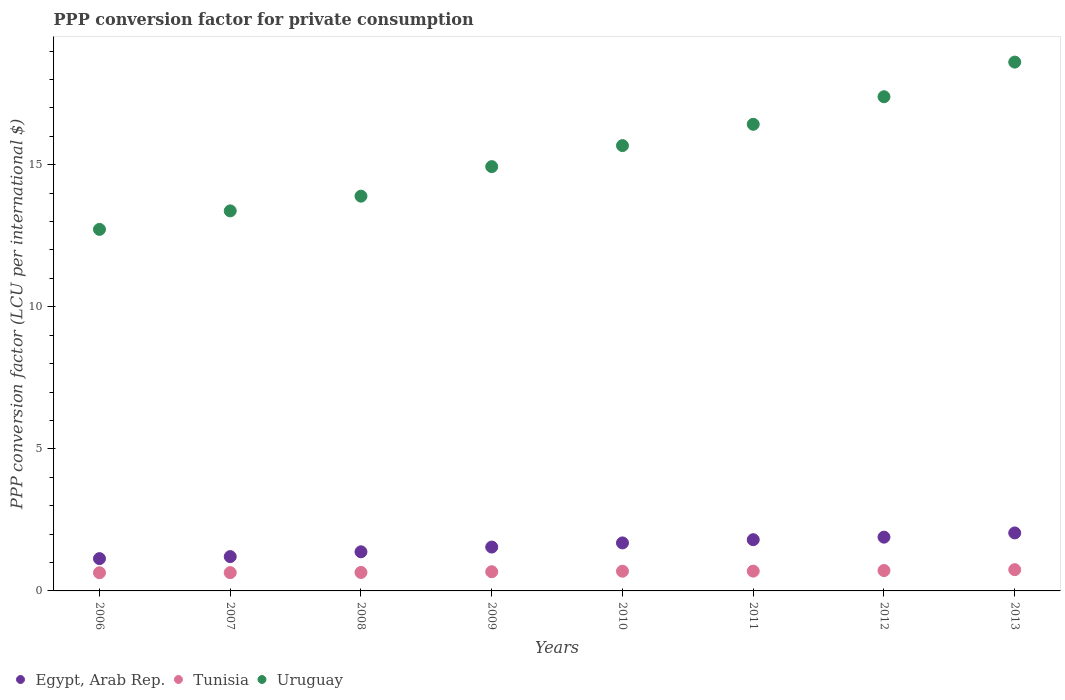How many different coloured dotlines are there?
Your answer should be compact. 3. Is the number of dotlines equal to the number of legend labels?
Make the answer very short. Yes. What is the PPP conversion factor for private consumption in Egypt, Arab Rep. in 2010?
Your answer should be compact. 1.69. Across all years, what is the maximum PPP conversion factor for private consumption in Uruguay?
Your response must be concise. 18.61. Across all years, what is the minimum PPP conversion factor for private consumption in Tunisia?
Keep it short and to the point. 0.64. In which year was the PPP conversion factor for private consumption in Egypt, Arab Rep. maximum?
Provide a succinct answer. 2013. In which year was the PPP conversion factor for private consumption in Tunisia minimum?
Ensure brevity in your answer.  2006. What is the total PPP conversion factor for private consumption in Tunisia in the graph?
Ensure brevity in your answer.  5.47. What is the difference between the PPP conversion factor for private consumption in Uruguay in 2007 and that in 2010?
Your answer should be very brief. -2.3. What is the difference between the PPP conversion factor for private consumption in Tunisia in 2006 and the PPP conversion factor for private consumption in Egypt, Arab Rep. in 2007?
Your response must be concise. -0.57. What is the average PPP conversion factor for private consumption in Egypt, Arab Rep. per year?
Keep it short and to the point. 1.59. In the year 2011, what is the difference between the PPP conversion factor for private consumption in Uruguay and PPP conversion factor for private consumption in Tunisia?
Your answer should be very brief. 15.73. In how many years, is the PPP conversion factor for private consumption in Tunisia greater than 18 LCU?
Offer a very short reply. 0. What is the ratio of the PPP conversion factor for private consumption in Egypt, Arab Rep. in 2008 to that in 2009?
Offer a very short reply. 0.89. Is the PPP conversion factor for private consumption in Egypt, Arab Rep. in 2006 less than that in 2011?
Provide a succinct answer. Yes. Is the difference between the PPP conversion factor for private consumption in Uruguay in 2008 and 2013 greater than the difference between the PPP conversion factor for private consumption in Tunisia in 2008 and 2013?
Make the answer very short. No. What is the difference between the highest and the second highest PPP conversion factor for private consumption in Uruguay?
Provide a short and direct response. 1.22. What is the difference between the highest and the lowest PPP conversion factor for private consumption in Uruguay?
Keep it short and to the point. 5.89. In how many years, is the PPP conversion factor for private consumption in Tunisia greater than the average PPP conversion factor for private consumption in Tunisia taken over all years?
Your answer should be very brief. 4. Is it the case that in every year, the sum of the PPP conversion factor for private consumption in Tunisia and PPP conversion factor for private consumption in Uruguay  is greater than the PPP conversion factor for private consumption in Egypt, Arab Rep.?
Your answer should be very brief. Yes. Does the PPP conversion factor for private consumption in Egypt, Arab Rep. monotonically increase over the years?
Offer a very short reply. Yes. Is the PPP conversion factor for private consumption in Egypt, Arab Rep. strictly greater than the PPP conversion factor for private consumption in Uruguay over the years?
Ensure brevity in your answer.  No. How many years are there in the graph?
Provide a succinct answer. 8. What is the difference between two consecutive major ticks on the Y-axis?
Your response must be concise. 5. Are the values on the major ticks of Y-axis written in scientific E-notation?
Give a very brief answer. No. Does the graph contain any zero values?
Give a very brief answer. No. Does the graph contain grids?
Offer a very short reply. No. How are the legend labels stacked?
Provide a short and direct response. Horizontal. What is the title of the graph?
Keep it short and to the point. PPP conversion factor for private consumption. What is the label or title of the X-axis?
Ensure brevity in your answer.  Years. What is the label or title of the Y-axis?
Offer a very short reply. PPP conversion factor (LCU per international $). What is the PPP conversion factor (LCU per international $) in Egypt, Arab Rep. in 2006?
Your answer should be very brief. 1.14. What is the PPP conversion factor (LCU per international $) of Tunisia in 2006?
Keep it short and to the point. 0.64. What is the PPP conversion factor (LCU per international $) of Uruguay in 2006?
Ensure brevity in your answer.  12.73. What is the PPP conversion factor (LCU per international $) in Egypt, Arab Rep. in 2007?
Give a very brief answer. 1.21. What is the PPP conversion factor (LCU per international $) of Tunisia in 2007?
Offer a very short reply. 0.64. What is the PPP conversion factor (LCU per international $) in Uruguay in 2007?
Offer a terse response. 13.38. What is the PPP conversion factor (LCU per international $) in Egypt, Arab Rep. in 2008?
Your answer should be compact. 1.38. What is the PPP conversion factor (LCU per international $) of Tunisia in 2008?
Offer a terse response. 0.65. What is the PPP conversion factor (LCU per international $) in Uruguay in 2008?
Your answer should be very brief. 13.89. What is the PPP conversion factor (LCU per international $) in Egypt, Arab Rep. in 2009?
Keep it short and to the point. 1.54. What is the PPP conversion factor (LCU per international $) in Tunisia in 2009?
Provide a succinct answer. 0.68. What is the PPP conversion factor (LCU per international $) of Uruguay in 2009?
Your response must be concise. 14.93. What is the PPP conversion factor (LCU per international $) of Egypt, Arab Rep. in 2010?
Offer a very short reply. 1.69. What is the PPP conversion factor (LCU per international $) in Tunisia in 2010?
Your answer should be compact. 0.69. What is the PPP conversion factor (LCU per international $) in Uruguay in 2010?
Your answer should be very brief. 15.67. What is the PPP conversion factor (LCU per international $) in Egypt, Arab Rep. in 2011?
Your response must be concise. 1.8. What is the PPP conversion factor (LCU per international $) in Tunisia in 2011?
Your answer should be very brief. 0.7. What is the PPP conversion factor (LCU per international $) in Uruguay in 2011?
Ensure brevity in your answer.  16.42. What is the PPP conversion factor (LCU per international $) in Egypt, Arab Rep. in 2012?
Keep it short and to the point. 1.89. What is the PPP conversion factor (LCU per international $) of Tunisia in 2012?
Your answer should be very brief. 0.72. What is the PPP conversion factor (LCU per international $) of Uruguay in 2012?
Provide a succinct answer. 17.39. What is the PPP conversion factor (LCU per international $) in Egypt, Arab Rep. in 2013?
Your answer should be compact. 2.04. What is the PPP conversion factor (LCU per international $) of Tunisia in 2013?
Ensure brevity in your answer.  0.75. What is the PPP conversion factor (LCU per international $) of Uruguay in 2013?
Your response must be concise. 18.61. Across all years, what is the maximum PPP conversion factor (LCU per international $) of Egypt, Arab Rep.?
Your answer should be compact. 2.04. Across all years, what is the maximum PPP conversion factor (LCU per international $) of Tunisia?
Your response must be concise. 0.75. Across all years, what is the maximum PPP conversion factor (LCU per international $) in Uruguay?
Your answer should be compact. 18.61. Across all years, what is the minimum PPP conversion factor (LCU per international $) of Egypt, Arab Rep.?
Offer a terse response. 1.14. Across all years, what is the minimum PPP conversion factor (LCU per international $) in Tunisia?
Your answer should be compact. 0.64. Across all years, what is the minimum PPP conversion factor (LCU per international $) in Uruguay?
Offer a very short reply. 12.73. What is the total PPP conversion factor (LCU per international $) in Egypt, Arab Rep. in the graph?
Make the answer very short. 12.69. What is the total PPP conversion factor (LCU per international $) of Tunisia in the graph?
Ensure brevity in your answer.  5.47. What is the total PPP conversion factor (LCU per international $) of Uruguay in the graph?
Offer a very short reply. 123.03. What is the difference between the PPP conversion factor (LCU per international $) of Egypt, Arab Rep. in 2006 and that in 2007?
Offer a terse response. -0.07. What is the difference between the PPP conversion factor (LCU per international $) in Tunisia in 2006 and that in 2007?
Your answer should be very brief. -0. What is the difference between the PPP conversion factor (LCU per international $) in Uruguay in 2006 and that in 2007?
Offer a very short reply. -0.65. What is the difference between the PPP conversion factor (LCU per international $) in Egypt, Arab Rep. in 2006 and that in 2008?
Provide a short and direct response. -0.24. What is the difference between the PPP conversion factor (LCU per international $) of Tunisia in 2006 and that in 2008?
Your response must be concise. -0.01. What is the difference between the PPP conversion factor (LCU per international $) of Uruguay in 2006 and that in 2008?
Your answer should be very brief. -1.17. What is the difference between the PPP conversion factor (LCU per international $) in Egypt, Arab Rep. in 2006 and that in 2009?
Make the answer very short. -0.41. What is the difference between the PPP conversion factor (LCU per international $) in Tunisia in 2006 and that in 2009?
Provide a succinct answer. -0.04. What is the difference between the PPP conversion factor (LCU per international $) in Uruguay in 2006 and that in 2009?
Give a very brief answer. -2.21. What is the difference between the PPP conversion factor (LCU per international $) of Egypt, Arab Rep. in 2006 and that in 2010?
Your answer should be very brief. -0.55. What is the difference between the PPP conversion factor (LCU per international $) in Tunisia in 2006 and that in 2010?
Provide a short and direct response. -0.05. What is the difference between the PPP conversion factor (LCU per international $) in Uruguay in 2006 and that in 2010?
Keep it short and to the point. -2.95. What is the difference between the PPP conversion factor (LCU per international $) in Egypt, Arab Rep. in 2006 and that in 2011?
Offer a terse response. -0.67. What is the difference between the PPP conversion factor (LCU per international $) of Tunisia in 2006 and that in 2011?
Offer a very short reply. -0.06. What is the difference between the PPP conversion factor (LCU per international $) of Uruguay in 2006 and that in 2011?
Your answer should be very brief. -3.7. What is the difference between the PPP conversion factor (LCU per international $) of Egypt, Arab Rep. in 2006 and that in 2012?
Offer a very short reply. -0.76. What is the difference between the PPP conversion factor (LCU per international $) in Tunisia in 2006 and that in 2012?
Give a very brief answer. -0.08. What is the difference between the PPP conversion factor (LCU per international $) in Uruguay in 2006 and that in 2012?
Offer a very short reply. -4.67. What is the difference between the PPP conversion factor (LCU per international $) of Egypt, Arab Rep. in 2006 and that in 2013?
Your response must be concise. -0.9. What is the difference between the PPP conversion factor (LCU per international $) in Tunisia in 2006 and that in 2013?
Keep it short and to the point. -0.11. What is the difference between the PPP conversion factor (LCU per international $) of Uruguay in 2006 and that in 2013?
Your response must be concise. -5.89. What is the difference between the PPP conversion factor (LCU per international $) in Egypt, Arab Rep. in 2007 and that in 2008?
Keep it short and to the point. -0.17. What is the difference between the PPP conversion factor (LCU per international $) of Tunisia in 2007 and that in 2008?
Your answer should be compact. -0.01. What is the difference between the PPP conversion factor (LCU per international $) of Uruguay in 2007 and that in 2008?
Ensure brevity in your answer.  -0.52. What is the difference between the PPP conversion factor (LCU per international $) in Egypt, Arab Rep. in 2007 and that in 2009?
Give a very brief answer. -0.34. What is the difference between the PPP conversion factor (LCU per international $) in Tunisia in 2007 and that in 2009?
Keep it short and to the point. -0.03. What is the difference between the PPP conversion factor (LCU per international $) in Uruguay in 2007 and that in 2009?
Keep it short and to the point. -1.56. What is the difference between the PPP conversion factor (LCU per international $) in Egypt, Arab Rep. in 2007 and that in 2010?
Your answer should be very brief. -0.48. What is the difference between the PPP conversion factor (LCU per international $) in Tunisia in 2007 and that in 2010?
Keep it short and to the point. -0.05. What is the difference between the PPP conversion factor (LCU per international $) of Uruguay in 2007 and that in 2010?
Offer a very short reply. -2.3. What is the difference between the PPP conversion factor (LCU per international $) of Egypt, Arab Rep. in 2007 and that in 2011?
Offer a very short reply. -0.59. What is the difference between the PPP conversion factor (LCU per international $) of Tunisia in 2007 and that in 2011?
Make the answer very short. -0.05. What is the difference between the PPP conversion factor (LCU per international $) in Uruguay in 2007 and that in 2011?
Ensure brevity in your answer.  -3.05. What is the difference between the PPP conversion factor (LCU per international $) in Egypt, Arab Rep. in 2007 and that in 2012?
Your answer should be compact. -0.68. What is the difference between the PPP conversion factor (LCU per international $) in Tunisia in 2007 and that in 2012?
Ensure brevity in your answer.  -0.07. What is the difference between the PPP conversion factor (LCU per international $) in Uruguay in 2007 and that in 2012?
Offer a terse response. -4.02. What is the difference between the PPP conversion factor (LCU per international $) of Egypt, Arab Rep. in 2007 and that in 2013?
Your response must be concise. -0.83. What is the difference between the PPP conversion factor (LCU per international $) of Tunisia in 2007 and that in 2013?
Offer a terse response. -0.1. What is the difference between the PPP conversion factor (LCU per international $) of Uruguay in 2007 and that in 2013?
Make the answer very short. -5.24. What is the difference between the PPP conversion factor (LCU per international $) of Egypt, Arab Rep. in 2008 and that in 2009?
Offer a terse response. -0.17. What is the difference between the PPP conversion factor (LCU per international $) of Tunisia in 2008 and that in 2009?
Provide a succinct answer. -0.03. What is the difference between the PPP conversion factor (LCU per international $) in Uruguay in 2008 and that in 2009?
Provide a succinct answer. -1.04. What is the difference between the PPP conversion factor (LCU per international $) of Egypt, Arab Rep. in 2008 and that in 2010?
Keep it short and to the point. -0.31. What is the difference between the PPP conversion factor (LCU per international $) of Tunisia in 2008 and that in 2010?
Your answer should be very brief. -0.04. What is the difference between the PPP conversion factor (LCU per international $) of Uruguay in 2008 and that in 2010?
Provide a short and direct response. -1.78. What is the difference between the PPP conversion factor (LCU per international $) of Egypt, Arab Rep. in 2008 and that in 2011?
Provide a short and direct response. -0.43. What is the difference between the PPP conversion factor (LCU per international $) of Tunisia in 2008 and that in 2011?
Offer a very short reply. -0.05. What is the difference between the PPP conversion factor (LCU per international $) in Uruguay in 2008 and that in 2011?
Provide a succinct answer. -2.53. What is the difference between the PPP conversion factor (LCU per international $) in Egypt, Arab Rep. in 2008 and that in 2012?
Offer a very short reply. -0.52. What is the difference between the PPP conversion factor (LCU per international $) in Tunisia in 2008 and that in 2012?
Give a very brief answer. -0.07. What is the difference between the PPP conversion factor (LCU per international $) of Uruguay in 2008 and that in 2012?
Your response must be concise. -3.5. What is the difference between the PPP conversion factor (LCU per international $) in Egypt, Arab Rep. in 2008 and that in 2013?
Provide a short and direct response. -0.66. What is the difference between the PPP conversion factor (LCU per international $) of Tunisia in 2008 and that in 2013?
Make the answer very short. -0.1. What is the difference between the PPP conversion factor (LCU per international $) in Uruguay in 2008 and that in 2013?
Ensure brevity in your answer.  -4.72. What is the difference between the PPP conversion factor (LCU per international $) in Egypt, Arab Rep. in 2009 and that in 2010?
Make the answer very short. -0.15. What is the difference between the PPP conversion factor (LCU per international $) in Tunisia in 2009 and that in 2010?
Provide a short and direct response. -0.02. What is the difference between the PPP conversion factor (LCU per international $) in Uruguay in 2009 and that in 2010?
Offer a very short reply. -0.74. What is the difference between the PPP conversion factor (LCU per international $) in Egypt, Arab Rep. in 2009 and that in 2011?
Ensure brevity in your answer.  -0.26. What is the difference between the PPP conversion factor (LCU per international $) of Tunisia in 2009 and that in 2011?
Keep it short and to the point. -0.02. What is the difference between the PPP conversion factor (LCU per international $) of Uruguay in 2009 and that in 2011?
Provide a succinct answer. -1.49. What is the difference between the PPP conversion factor (LCU per international $) of Egypt, Arab Rep. in 2009 and that in 2012?
Provide a succinct answer. -0.35. What is the difference between the PPP conversion factor (LCU per international $) in Tunisia in 2009 and that in 2012?
Offer a terse response. -0.04. What is the difference between the PPP conversion factor (LCU per international $) in Uruguay in 2009 and that in 2012?
Your response must be concise. -2.46. What is the difference between the PPP conversion factor (LCU per international $) in Egypt, Arab Rep. in 2009 and that in 2013?
Provide a short and direct response. -0.5. What is the difference between the PPP conversion factor (LCU per international $) of Tunisia in 2009 and that in 2013?
Your answer should be very brief. -0.07. What is the difference between the PPP conversion factor (LCU per international $) of Uruguay in 2009 and that in 2013?
Make the answer very short. -3.68. What is the difference between the PPP conversion factor (LCU per international $) in Egypt, Arab Rep. in 2010 and that in 2011?
Provide a short and direct response. -0.11. What is the difference between the PPP conversion factor (LCU per international $) in Tunisia in 2010 and that in 2011?
Your answer should be compact. -0. What is the difference between the PPP conversion factor (LCU per international $) in Uruguay in 2010 and that in 2011?
Provide a succinct answer. -0.75. What is the difference between the PPP conversion factor (LCU per international $) of Egypt, Arab Rep. in 2010 and that in 2012?
Provide a succinct answer. -0.2. What is the difference between the PPP conversion factor (LCU per international $) of Tunisia in 2010 and that in 2012?
Keep it short and to the point. -0.02. What is the difference between the PPP conversion factor (LCU per international $) in Uruguay in 2010 and that in 2012?
Give a very brief answer. -1.72. What is the difference between the PPP conversion factor (LCU per international $) in Egypt, Arab Rep. in 2010 and that in 2013?
Your answer should be compact. -0.35. What is the difference between the PPP conversion factor (LCU per international $) of Tunisia in 2010 and that in 2013?
Offer a very short reply. -0.05. What is the difference between the PPP conversion factor (LCU per international $) in Uruguay in 2010 and that in 2013?
Provide a short and direct response. -2.94. What is the difference between the PPP conversion factor (LCU per international $) of Egypt, Arab Rep. in 2011 and that in 2012?
Offer a terse response. -0.09. What is the difference between the PPP conversion factor (LCU per international $) in Tunisia in 2011 and that in 2012?
Your response must be concise. -0.02. What is the difference between the PPP conversion factor (LCU per international $) of Uruguay in 2011 and that in 2012?
Offer a terse response. -0.97. What is the difference between the PPP conversion factor (LCU per international $) in Egypt, Arab Rep. in 2011 and that in 2013?
Give a very brief answer. -0.24. What is the difference between the PPP conversion factor (LCU per international $) in Tunisia in 2011 and that in 2013?
Make the answer very short. -0.05. What is the difference between the PPP conversion factor (LCU per international $) of Uruguay in 2011 and that in 2013?
Your answer should be compact. -2.19. What is the difference between the PPP conversion factor (LCU per international $) of Egypt, Arab Rep. in 2012 and that in 2013?
Give a very brief answer. -0.15. What is the difference between the PPP conversion factor (LCU per international $) of Tunisia in 2012 and that in 2013?
Your response must be concise. -0.03. What is the difference between the PPP conversion factor (LCU per international $) of Uruguay in 2012 and that in 2013?
Offer a terse response. -1.22. What is the difference between the PPP conversion factor (LCU per international $) of Egypt, Arab Rep. in 2006 and the PPP conversion factor (LCU per international $) of Tunisia in 2007?
Provide a short and direct response. 0.49. What is the difference between the PPP conversion factor (LCU per international $) in Egypt, Arab Rep. in 2006 and the PPP conversion factor (LCU per international $) in Uruguay in 2007?
Provide a succinct answer. -12.24. What is the difference between the PPP conversion factor (LCU per international $) of Tunisia in 2006 and the PPP conversion factor (LCU per international $) of Uruguay in 2007?
Your answer should be compact. -12.74. What is the difference between the PPP conversion factor (LCU per international $) in Egypt, Arab Rep. in 2006 and the PPP conversion factor (LCU per international $) in Tunisia in 2008?
Offer a terse response. 0.49. What is the difference between the PPP conversion factor (LCU per international $) of Egypt, Arab Rep. in 2006 and the PPP conversion factor (LCU per international $) of Uruguay in 2008?
Keep it short and to the point. -12.76. What is the difference between the PPP conversion factor (LCU per international $) of Tunisia in 2006 and the PPP conversion factor (LCU per international $) of Uruguay in 2008?
Make the answer very short. -13.25. What is the difference between the PPP conversion factor (LCU per international $) of Egypt, Arab Rep. in 2006 and the PPP conversion factor (LCU per international $) of Tunisia in 2009?
Give a very brief answer. 0.46. What is the difference between the PPP conversion factor (LCU per international $) in Egypt, Arab Rep. in 2006 and the PPP conversion factor (LCU per international $) in Uruguay in 2009?
Keep it short and to the point. -13.8. What is the difference between the PPP conversion factor (LCU per international $) of Tunisia in 2006 and the PPP conversion factor (LCU per international $) of Uruguay in 2009?
Offer a very short reply. -14.29. What is the difference between the PPP conversion factor (LCU per international $) in Egypt, Arab Rep. in 2006 and the PPP conversion factor (LCU per international $) in Tunisia in 2010?
Give a very brief answer. 0.44. What is the difference between the PPP conversion factor (LCU per international $) in Egypt, Arab Rep. in 2006 and the PPP conversion factor (LCU per international $) in Uruguay in 2010?
Make the answer very short. -14.54. What is the difference between the PPP conversion factor (LCU per international $) in Tunisia in 2006 and the PPP conversion factor (LCU per international $) in Uruguay in 2010?
Make the answer very short. -15.03. What is the difference between the PPP conversion factor (LCU per international $) in Egypt, Arab Rep. in 2006 and the PPP conversion factor (LCU per international $) in Tunisia in 2011?
Provide a succinct answer. 0.44. What is the difference between the PPP conversion factor (LCU per international $) of Egypt, Arab Rep. in 2006 and the PPP conversion factor (LCU per international $) of Uruguay in 2011?
Ensure brevity in your answer.  -15.29. What is the difference between the PPP conversion factor (LCU per international $) of Tunisia in 2006 and the PPP conversion factor (LCU per international $) of Uruguay in 2011?
Make the answer very short. -15.78. What is the difference between the PPP conversion factor (LCU per international $) of Egypt, Arab Rep. in 2006 and the PPP conversion factor (LCU per international $) of Tunisia in 2012?
Make the answer very short. 0.42. What is the difference between the PPP conversion factor (LCU per international $) in Egypt, Arab Rep. in 2006 and the PPP conversion factor (LCU per international $) in Uruguay in 2012?
Your answer should be compact. -16.26. What is the difference between the PPP conversion factor (LCU per international $) of Tunisia in 2006 and the PPP conversion factor (LCU per international $) of Uruguay in 2012?
Provide a succinct answer. -16.75. What is the difference between the PPP conversion factor (LCU per international $) in Egypt, Arab Rep. in 2006 and the PPP conversion factor (LCU per international $) in Tunisia in 2013?
Your answer should be very brief. 0.39. What is the difference between the PPP conversion factor (LCU per international $) in Egypt, Arab Rep. in 2006 and the PPP conversion factor (LCU per international $) in Uruguay in 2013?
Ensure brevity in your answer.  -17.48. What is the difference between the PPP conversion factor (LCU per international $) of Tunisia in 2006 and the PPP conversion factor (LCU per international $) of Uruguay in 2013?
Ensure brevity in your answer.  -17.97. What is the difference between the PPP conversion factor (LCU per international $) of Egypt, Arab Rep. in 2007 and the PPP conversion factor (LCU per international $) of Tunisia in 2008?
Ensure brevity in your answer.  0.56. What is the difference between the PPP conversion factor (LCU per international $) in Egypt, Arab Rep. in 2007 and the PPP conversion factor (LCU per international $) in Uruguay in 2008?
Make the answer very short. -12.69. What is the difference between the PPP conversion factor (LCU per international $) in Tunisia in 2007 and the PPP conversion factor (LCU per international $) in Uruguay in 2008?
Offer a very short reply. -13.25. What is the difference between the PPP conversion factor (LCU per international $) in Egypt, Arab Rep. in 2007 and the PPP conversion factor (LCU per international $) in Tunisia in 2009?
Offer a terse response. 0.53. What is the difference between the PPP conversion factor (LCU per international $) in Egypt, Arab Rep. in 2007 and the PPP conversion factor (LCU per international $) in Uruguay in 2009?
Make the answer very short. -13.73. What is the difference between the PPP conversion factor (LCU per international $) in Tunisia in 2007 and the PPP conversion factor (LCU per international $) in Uruguay in 2009?
Offer a terse response. -14.29. What is the difference between the PPP conversion factor (LCU per international $) of Egypt, Arab Rep. in 2007 and the PPP conversion factor (LCU per international $) of Tunisia in 2010?
Offer a terse response. 0.51. What is the difference between the PPP conversion factor (LCU per international $) in Egypt, Arab Rep. in 2007 and the PPP conversion factor (LCU per international $) in Uruguay in 2010?
Provide a short and direct response. -14.47. What is the difference between the PPP conversion factor (LCU per international $) of Tunisia in 2007 and the PPP conversion factor (LCU per international $) of Uruguay in 2010?
Your answer should be compact. -15.03. What is the difference between the PPP conversion factor (LCU per international $) of Egypt, Arab Rep. in 2007 and the PPP conversion factor (LCU per international $) of Tunisia in 2011?
Offer a very short reply. 0.51. What is the difference between the PPP conversion factor (LCU per international $) of Egypt, Arab Rep. in 2007 and the PPP conversion factor (LCU per international $) of Uruguay in 2011?
Your response must be concise. -15.22. What is the difference between the PPP conversion factor (LCU per international $) of Tunisia in 2007 and the PPP conversion factor (LCU per international $) of Uruguay in 2011?
Keep it short and to the point. -15.78. What is the difference between the PPP conversion factor (LCU per international $) of Egypt, Arab Rep. in 2007 and the PPP conversion factor (LCU per international $) of Tunisia in 2012?
Offer a terse response. 0.49. What is the difference between the PPP conversion factor (LCU per international $) of Egypt, Arab Rep. in 2007 and the PPP conversion factor (LCU per international $) of Uruguay in 2012?
Provide a short and direct response. -16.19. What is the difference between the PPP conversion factor (LCU per international $) of Tunisia in 2007 and the PPP conversion factor (LCU per international $) of Uruguay in 2012?
Your answer should be compact. -16.75. What is the difference between the PPP conversion factor (LCU per international $) in Egypt, Arab Rep. in 2007 and the PPP conversion factor (LCU per international $) in Tunisia in 2013?
Offer a terse response. 0.46. What is the difference between the PPP conversion factor (LCU per international $) of Egypt, Arab Rep. in 2007 and the PPP conversion factor (LCU per international $) of Uruguay in 2013?
Ensure brevity in your answer.  -17.4. What is the difference between the PPP conversion factor (LCU per international $) in Tunisia in 2007 and the PPP conversion factor (LCU per international $) in Uruguay in 2013?
Keep it short and to the point. -17.97. What is the difference between the PPP conversion factor (LCU per international $) of Egypt, Arab Rep. in 2008 and the PPP conversion factor (LCU per international $) of Tunisia in 2009?
Your response must be concise. 0.7. What is the difference between the PPP conversion factor (LCU per international $) in Egypt, Arab Rep. in 2008 and the PPP conversion factor (LCU per international $) in Uruguay in 2009?
Provide a succinct answer. -13.56. What is the difference between the PPP conversion factor (LCU per international $) of Tunisia in 2008 and the PPP conversion factor (LCU per international $) of Uruguay in 2009?
Offer a terse response. -14.28. What is the difference between the PPP conversion factor (LCU per international $) of Egypt, Arab Rep. in 2008 and the PPP conversion factor (LCU per international $) of Tunisia in 2010?
Make the answer very short. 0.68. What is the difference between the PPP conversion factor (LCU per international $) of Egypt, Arab Rep. in 2008 and the PPP conversion factor (LCU per international $) of Uruguay in 2010?
Keep it short and to the point. -14.3. What is the difference between the PPP conversion factor (LCU per international $) in Tunisia in 2008 and the PPP conversion factor (LCU per international $) in Uruguay in 2010?
Make the answer very short. -15.02. What is the difference between the PPP conversion factor (LCU per international $) in Egypt, Arab Rep. in 2008 and the PPP conversion factor (LCU per international $) in Tunisia in 2011?
Ensure brevity in your answer.  0.68. What is the difference between the PPP conversion factor (LCU per international $) in Egypt, Arab Rep. in 2008 and the PPP conversion factor (LCU per international $) in Uruguay in 2011?
Provide a short and direct response. -15.05. What is the difference between the PPP conversion factor (LCU per international $) of Tunisia in 2008 and the PPP conversion factor (LCU per international $) of Uruguay in 2011?
Your answer should be very brief. -15.77. What is the difference between the PPP conversion factor (LCU per international $) of Egypt, Arab Rep. in 2008 and the PPP conversion factor (LCU per international $) of Tunisia in 2012?
Provide a succinct answer. 0.66. What is the difference between the PPP conversion factor (LCU per international $) of Egypt, Arab Rep. in 2008 and the PPP conversion factor (LCU per international $) of Uruguay in 2012?
Keep it short and to the point. -16.02. What is the difference between the PPP conversion factor (LCU per international $) of Tunisia in 2008 and the PPP conversion factor (LCU per international $) of Uruguay in 2012?
Give a very brief answer. -16.74. What is the difference between the PPP conversion factor (LCU per international $) in Egypt, Arab Rep. in 2008 and the PPP conversion factor (LCU per international $) in Tunisia in 2013?
Keep it short and to the point. 0.63. What is the difference between the PPP conversion factor (LCU per international $) of Egypt, Arab Rep. in 2008 and the PPP conversion factor (LCU per international $) of Uruguay in 2013?
Provide a short and direct response. -17.24. What is the difference between the PPP conversion factor (LCU per international $) of Tunisia in 2008 and the PPP conversion factor (LCU per international $) of Uruguay in 2013?
Ensure brevity in your answer.  -17.96. What is the difference between the PPP conversion factor (LCU per international $) in Egypt, Arab Rep. in 2009 and the PPP conversion factor (LCU per international $) in Tunisia in 2010?
Give a very brief answer. 0.85. What is the difference between the PPP conversion factor (LCU per international $) of Egypt, Arab Rep. in 2009 and the PPP conversion factor (LCU per international $) of Uruguay in 2010?
Provide a succinct answer. -14.13. What is the difference between the PPP conversion factor (LCU per international $) in Tunisia in 2009 and the PPP conversion factor (LCU per international $) in Uruguay in 2010?
Your answer should be very brief. -15. What is the difference between the PPP conversion factor (LCU per international $) of Egypt, Arab Rep. in 2009 and the PPP conversion factor (LCU per international $) of Tunisia in 2011?
Offer a terse response. 0.85. What is the difference between the PPP conversion factor (LCU per international $) of Egypt, Arab Rep. in 2009 and the PPP conversion factor (LCU per international $) of Uruguay in 2011?
Your answer should be compact. -14.88. What is the difference between the PPP conversion factor (LCU per international $) in Tunisia in 2009 and the PPP conversion factor (LCU per international $) in Uruguay in 2011?
Your answer should be very brief. -15.75. What is the difference between the PPP conversion factor (LCU per international $) of Egypt, Arab Rep. in 2009 and the PPP conversion factor (LCU per international $) of Tunisia in 2012?
Provide a short and direct response. 0.83. What is the difference between the PPP conversion factor (LCU per international $) of Egypt, Arab Rep. in 2009 and the PPP conversion factor (LCU per international $) of Uruguay in 2012?
Your answer should be very brief. -15.85. What is the difference between the PPP conversion factor (LCU per international $) of Tunisia in 2009 and the PPP conversion factor (LCU per international $) of Uruguay in 2012?
Provide a short and direct response. -16.72. What is the difference between the PPP conversion factor (LCU per international $) of Egypt, Arab Rep. in 2009 and the PPP conversion factor (LCU per international $) of Tunisia in 2013?
Your answer should be very brief. 0.8. What is the difference between the PPP conversion factor (LCU per international $) of Egypt, Arab Rep. in 2009 and the PPP conversion factor (LCU per international $) of Uruguay in 2013?
Provide a succinct answer. -17.07. What is the difference between the PPP conversion factor (LCU per international $) of Tunisia in 2009 and the PPP conversion factor (LCU per international $) of Uruguay in 2013?
Ensure brevity in your answer.  -17.94. What is the difference between the PPP conversion factor (LCU per international $) of Egypt, Arab Rep. in 2010 and the PPP conversion factor (LCU per international $) of Tunisia in 2011?
Give a very brief answer. 0.99. What is the difference between the PPP conversion factor (LCU per international $) of Egypt, Arab Rep. in 2010 and the PPP conversion factor (LCU per international $) of Uruguay in 2011?
Provide a succinct answer. -14.73. What is the difference between the PPP conversion factor (LCU per international $) in Tunisia in 2010 and the PPP conversion factor (LCU per international $) in Uruguay in 2011?
Your answer should be compact. -15.73. What is the difference between the PPP conversion factor (LCU per international $) in Egypt, Arab Rep. in 2010 and the PPP conversion factor (LCU per international $) in Tunisia in 2012?
Offer a terse response. 0.97. What is the difference between the PPP conversion factor (LCU per international $) of Egypt, Arab Rep. in 2010 and the PPP conversion factor (LCU per international $) of Uruguay in 2012?
Your answer should be compact. -15.7. What is the difference between the PPP conversion factor (LCU per international $) in Tunisia in 2010 and the PPP conversion factor (LCU per international $) in Uruguay in 2012?
Give a very brief answer. -16.7. What is the difference between the PPP conversion factor (LCU per international $) of Egypt, Arab Rep. in 2010 and the PPP conversion factor (LCU per international $) of Tunisia in 2013?
Provide a short and direct response. 0.94. What is the difference between the PPP conversion factor (LCU per international $) of Egypt, Arab Rep. in 2010 and the PPP conversion factor (LCU per international $) of Uruguay in 2013?
Provide a short and direct response. -16.92. What is the difference between the PPP conversion factor (LCU per international $) in Tunisia in 2010 and the PPP conversion factor (LCU per international $) in Uruguay in 2013?
Your answer should be very brief. -17.92. What is the difference between the PPP conversion factor (LCU per international $) of Egypt, Arab Rep. in 2011 and the PPP conversion factor (LCU per international $) of Tunisia in 2012?
Your answer should be compact. 1.09. What is the difference between the PPP conversion factor (LCU per international $) in Egypt, Arab Rep. in 2011 and the PPP conversion factor (LCU per international $) in Uruguay in 2012?
Give a very brief answer. -15.59. What is the difference between the PPP conversion factor (LCU per international $) of Tunisia in 2011 and the PPP conversion factor (LCU per international $) of Uruguay in 2012?
Your response must be concise. -16.7. What is the difference between the PPP conversion factor (LCU per international $) in Egypt, Arab Rep. in 2011 and the PPP conversion factor (LCU per international $) in Tunisia in 2013?
Offer a terse response. 1.05. What is the difference between the PPP conversion factor (LCU per international $) in Egypt, Arab Rep. in 2011 and the PPP conversion factor (LCU per international $) in Uruguay in 2013?
Your answer should be very brief. -16.81. What is the difference between the PPP conversion factor (LCU per international $) of Tunisia in 2011 and the PPP conversion factor (LCU per international $) of Uruguay in 2013?
Offer a very short reply. -17.92. What is the difference between the PPP conversion factor (LCU per international $) of Egypt, Arab Rep. in 2012 and the PPP conversion factor (LCU per international $) of Tunisia in 2013?
Offer a terse response. 1.14. What is the difference between the PPP conversion factor (LCU per international $) in Egypt, Arab Rep. in 2012 and the PPP conversion factor (LCU per international $) in Uruguay in 2013?
Offer a terse response. -16.72. What is the difference between the PPP conversion factor (LCU per international $) of Tunisia in 2012 and the PPP conversion factor (LCU per international $) of Uruguay in 2013?
Your answer should be compact. -17.9. What is the average PPP conversion factor (LCU per international $) in Egypt, Arab Rep. per year?
Your response must be concise. 1.59. What is the average PPP conversion factor (LCU per international $) of Tunisia per year?
Provide a short and direct response. 0.68. What is the average PPP conversion factor (LCU per international $) in Uruguay per year?
Offer a terse response. 15.38. In the year 2006, what is the difference between the PPP conversion factor (LCU per international $) of Egypt, Arab Rep. and PPP conversion factor (LCU per international $) of Tunisia?
Provide a short and direct response. 0.5. In the year 2006, what is the difference between the PPP conversion factor (LCU per international $) of Egypt, Arab Rep. and PPP conversion factor (LCU per international $) of Uruguay?
Your answer should be compact. -11.59. In the year 2006, what is the difference between the PPP conversion factor (LCU per international $) in Tunisia and PPP conversion factor (LCU per international $) in Uruguay?
Provide a short and direct response. -12.09. In the year 2007, what is the difference between the PPP conversion factor (LCU per international $) in Egypt, Arab Rep. and PPP conversion factor (LCU per international $) in Tunisia?
Keep it short and to the point. 0.56. In the year 2007, what is the difference between the PPP conversion factor (LCU per international $) of Egypt, Arab Rep. and PPP conversion factor (LCU per international $) of Uruguay?
Ensure brevity in your answer.  -12.17. In the year 2007, what is the difference between the PPP conversion factor (LCU per international $) of Tunisia and PPP conversion factor (LCU per international $) of Uruguay?
Offer a terse response. -12.73. In the year 2008, what is the difference between the PPP conversion factor (LCU per international $) of Egypt, Arab Rep. and PPP conversion factor (LCU per international $) of Tunisia?
Your answer should be very brief. 0.73. In the year 2008, what is the difference between the PPP conversion factor (LCU per international $) of Egypt, Arab Rep. and PPP conversion factor (LCU per international $) of Uruguay?
Give a very brief answer. -12.52. In the year 2008, what is the difference between the PPP conversion factor (LCU per international $) of Tunisia and PPP conversion factor (LCU per international $) of Uruguay?
Offer a terse response. -13.24. In the year 2009, what is the difference between the PPP conversion factor (LCU per international $) of Egypt, Arab Rep. and PPP conversion factor (LCU per international $) of Tunisia?
Your answer should be compact. 0.87. In the year 2009, what is the difference between the PPP conversion factor (LCU per international $) of Egypt, Arab Rep. and PPP conversion factor (LCU per international $) of Uruguay?
Give a very brief answer. -13.39. In the year 2009, what is the difference between the PPP conversion factor (LCU per international $) in Tunisia and PPP conversion factor (LCU per international $) in Uruguay?
Ensure brevity in your answer.  -14.26. In the year 2010, what is the difference between the PPP conversion factor (LCU per international $) in Egypt, Arab Rep. and PPP conversion factor (LCU per international $) in Tunisia?
Provide a short and direct response. 1. In the year 2010, what is the difference between the PPP conversion factor (LCU per international $) of Egypt, Arab Rep. and PPP conversion factor (LCU per international $) of Uruguay?
Offer a very short reply. -13.98. In the year 2010, what is the difference between the PPP conversion factor (LCU per international $) in Tunisia and PPP conversion factor (LCU per international $) in Uruguay?
Keep it short and to the point. -14.98. In the year 2011, what is the difference between the PPP conversion factor (LCU per international $) in Egypt, Arab Rep. and PPP conversion factor (LCU per international $) in Tunisia?
Your answer should be compact. 1.11. In the year 2011, what is the difference between the PPP conversion factor (LCU per international $) in Egypt, Arab Rep. and PPP conversion factor (LCU per international $) in Uruguay?
Ensure brevity in your answer.  -14.62. In the year 2011, what is the difference between the PPP conversion factor (LCU per international $) in Tunisia and PPP conversion factor (LCU per international $) in Uruguay?
Offer a terse response. -15.73. In the year 2012, what is the difference between the PPP conversion factor (LCU per international $) of Egypt, Arab Rep. and PPP conversion factor (LCU per international $) of Tunisia?
Your response must be concise. 1.17. In the year 2012, what is the difference between the PPP conversion factor (LCU per international $) in Egypt, Arab Rep. and PPP conversion factor (LCU per international $) in Uruguay?
Make the answer very short. -15.5. In the year 2012, what is the difference between the PPP conversion factor (LCU per international $) in Tunisia and PPP conversion factor (LCU per international $) in Uruguay?
Make the answer very short. -16.68. In the year 2013, what is the difference between the PPP conversion factor (LCU per international $) in Egypt, Arab Rep. and PPP conversion factor (LCU per international $) in Tunisia?
Give a very brief answer. 1.29. In the year 2013, what is the difference between the PPP conversion factor (LCU per international $) in Egypt, Arab Rep. and PPP conversion factor (LCU per international $) in Uruguay?
Make the answer very short. -16.57. In the year 2013, what is the difference between the PPP conversion factor (LCU per international $) of Tunisia and PPP conversion factor (LCU per international $) of Uruguay?
Offer a very short reply. -17.86. What is the ratio of the PPP conversion factor (LCU per international $) in Egypt, Arab Rep. in 2006 to that in 2007?
Provide a short and direct response. 0.94. What is the ratio of the PPP conversion factor (LCU per international $) of Uruguay in 2006 to that in 2007?
Ensure brevity in your answer.  0.95. What is the ratio of the PPP conversion factor (LCU per international $) of Egypt, Arab Rep. in 2006 to that in 2008?
Your answer should be compact. 0.83. What is the ratio of the PPP conversion factor (LCU per international $) of Tunisia in 2006 to that in 2008?
Provide a succinct answer. 0.98. What is the ratio of the PPP conversion factor (LCU per international $) in Uruguay in 2006 to that in 2008?
Your answer should be compact. 0.92. What is the ratio of the PPP conversion factor (LCU per international $) of Egypt, Arab Rep. in 2006 to that in 2009?
Keep it short and to the point. 0.74. What is the ratio of the PPP conversion factor (LCU per international $) of Uruguay in 2006 to that in 2009?
Ensure brevity in your answer.  0.85. What is the ratio of the PPP conversion factor (LCU per international $) of Egypt, Arab Rep. in 2006 to that in 2010?
Give a very brief answer. 0.67. What is the ratio of the PPP conversion factor (LCU per international $) in Tunisia in 2006 to that in 2010?
Make the answer very short. 0.92. What is the ratio of the PPP conversion factor (LCU per international $) of Uruguay in 2006 to that in 2010?
Your response must be concise. 0.81. What is the ratio of the PPP conversion factor (LCU per international $) in Egypt, Arab Rep. in 2006 to that in 2011?
Give a very brief answer. 0.63. What is the ratio of the PPP conversion factor (LCU per international $) in Tunisia in 2006 to that in 2011?
Your answer should be very brief. 0.92. What is the ratio of the PPP conversion factor (LCU per international $) of Uruguay in 2006 to that in 2011?
Your answer should be very brief. 0.77. What is the ratio of the PPP conversion factor (LCU per international $) of Egypt, Arab Rep. in 2006 to that in 2012?
Make the answer very short. 0.6. What is the ratio of the PPP conversion factor (LCU per international $) in Tunisia in 2006 to that in 2012?
Offer a very short reply. 0.89. What is the ratio of the PPP conversion factor (LCU per international $) in Uruguay in 2006 to that in 2012?
Provide a short and direct response. 0.73. What is the ratio of the PPP conversion factor (LCU per international $) in Egypt, Arab Rep. in 2006 to that in 2013?
Give a very brief answer. 0.56. What is the ratio of the PPP conversion factor (LCU per international $) in Tunisia in 2006 to that in 2013?
Provide a succinct answer. 0.86. What is the ratio of the PPP conversion factor (LCU per international $) of Uruguay in 2006 to that in 2013?
Give a very brief answer. 0.68. What is the ratio of the PPP conversion factor (LCU per international $) in Egypt, Arab Rep. in 2007 to that in 2008?
Give a very brief answer. 0.88. What is the ratio of the PPP conversion factor (LCU per international $) of Uruguay in 2007 to that in 2008?
Your answer should be compact. 0.96. What is the ratio of the PPP conversion factor (LCU per international $) of Egypt, Arab Rep. in 2007 to that in 2009?
Your answer should be very brief. 0.78. What is the ratio of the PPP conversion factor (LCU per international $) of Tunisia in 2007 to that in 2009?
Keep it short and to the point. 0.95. What is the ratio of the PPP conversion factor (LCU per international $) in Uruguay in 2007 to that in 2009?
Make the answer very short. 0.9. What is the ratio of the PPP conversion factor (LCU per international $) of Egypt, Arab Rep. in 2007 to that in 2010?
Keep it short and to the point. 0.71. What is the ratio of the PPP conversion factor (LCU per international $) of Tunisia in 2007 to that in 2010?
Your answer should be very brief. 0.93. What is the ratio of the PPP conversion factor (LCU per international $) in Uruguay in 2007 to that in 2010?
Provide a succinct answer. 0.85. What is the ratio of the PPP conversion factor (LCU per international $) in Egypt, Arab Rep. in 2007 to that in 2011?
Your response must be concise. 0.67. What is the ratio of the PPP conversion factor (LCU per international $) of Tunisia in 2007 to that in 2011?
Give a very brief answer. 0.92. What is the ratio of the PPP conversion factor (LCU per international $) of Uruguay in 2007 to that in 2011?
Ensure brevity in your answer.  0.81. What is the ratio of the PPP conversion factor (LCU per international $) of Egypt, Arab Rep. in 2007 to that in 2012?
Give a very brief answer. 0.64. What is the ratio of the PPP conversion factor (LCU per international $) in Tunisia in 2007 to that in 2012?
Provide a succinct answer. 0.9. What is the ratio of the PPP conversion factor (LCU per international $) in Uruguay in 2007 to that in 2012?
Your answer should be compact. 0.77. What is the ratio of the PPP conversion factor (LCU per international $) in Egypt, Arab Rep. in 2007 to that in 2013?
Make the answer very short. 0.59. What is the ratio of the PPP conversion factor (LCU per international $) in Tunisia in 2007 to that in 2013?
Your answer should be compact. 0.86. What is the ratio of the PPP conversion factor (LCU per international $) in Uruguay in 2007 to that in 2013?
Offer a terse response. 0.72. What is the ratio of the PPP conversion factor (LCU per international $) of Egypt, Arab Rep. in 2008 to that in 2009?
Your answer should be compact. 0.89. What is the ratio of the PPP conversion factor (LCU per international $) in Tunisia in 2008 to that in 2009?
Offer a terse response. 0.96. What is the ratio of the PPP conversion factor (LCU per international $) in Uruguay in 2008 to that in 2009?
Make the answer very short. 0.93. What is the ratio of the PPP conversion factor (LCU per international $) in Egypt, Arab Rep. in 2008 to that in 2010?
Give a very brief answer. 0.81. What is the ratio of the PPP conversion factor (LCU per international $) of Tunisia in 2008 to that in 2010?
Keep it short and to the point. 0.94. What is the ratio of the PPP conversion factor (LCU per international $) of Uruguay in 2008 to that in 2010?
Keep it short and to the point. 0.89. What is the ratio of the PPP conversion factor (LCU per international $) of Egypt, Arab Rep. in 2008 to that in 2011?
Keep it short and to the point. 0.76. What is the ratio of the PPP conversion factor (LCU per international $) of Tunisia in 2008 to that in 2011?
Your response must be concise. 0.93. What is the ratio of the PPP conversion factor (LCU per international $) in Uruguay in 2008 to that in 2011?
Give a very brief answer. 0.85. What is the ratio of the PPP conversion factor (LCU per international $) of Egypt, Arab Rep. in 2008 to that in 2012?
Your answer should be compact. 0.73. What is the ratio of the PPP conversion factor (LCU per international $) in Tunisia in 2008 to that in 2012?
Give a very brief answer. 0.91. What is the ratio of the PPP conversion factor (LCU per international $) in Uruguay in 2008 to that in 2012?
Ensure brevity in your answer.  0.8. What is the ratio of the PPP conversion factor (LCU per international $) of Egypt, Arab Rep. in 2008 to that in 2013?
Give a very brief answer. 0.67. What is the ratio of the PPP conversion factor (LCU per international $) in Tunisia in 2008 to that in 2013?
Your response must be concise. 0.87. What is the ratio of the PPP conversion factor (LCU per international $) of Uruguay in 2008 to that in 2013?
Ensure brevity in your answer.  0.75. What is the ratio of the PPP conversion factor (LCU per international $) of Egypt, Arab Rep. in 2009 to that in 2010?
Keep it short and to the point. 0.91. What is the ratio of the PPP conversion factor (LCU per international $) of Tunisia in 2009 to that in 2010?
Provide a succinct answer. 0.97. What is the ratio of the PPP conversion factor (LCU per international $) of Uruguay in 2009 to that in 2010?
Your response must be concise. 0.95. What is the ratio of the PPP conversion factor (LCU per international $) of Egypt, Arab Rep. in 2009 to that in 2011?
Offer a very short reply. 0.86. What is the ratio of the PPP conversion factor (LCU per international $) of Tunisia in 2009 to that in 2011?
Make the answer very short. 0.97. What is the ratio of the PPP conversion factor (LCU per international $) in Uruguay in 2009 to that in 2011?
Make the answer very short. 0.91. What is the ratio of the PPP conversion factor (LCU per international $) in Egypt, Arab Rep. in 2009 to that in 2012?
Ensure brevity in your answer.  0.82. What is the ratio of the PPP conversion factor (LCU per international $) in Tunisia in 2009 to that in 2012?
Offer a terse response. 0.94. What is the ratio of the PPP conversion factor (LCU per international $) of Uruguay in 2009 to that in 2012?
Ensure brevity in your answer.  0.86. What is the ratio of the PPP conversion factor (LCU per international $) in Egypt, Arab Rep. in 2009 to that in 2013?
Keep it short and to the point. 0.76. What is the ratio of the PPP conversion factor (LCU per international $) in Tunisia in 2009 to that in 2013?
Offer a very short reply. 0.9. What is the ratio of the PPP conversion factor (LCU per international $) in Uruguay in 2009 to that in 2013?
Your answer should be very brief. 0.8. What is the ratio of the PPP conversion factor (LCU per international $) in Egypt, Arab Rep. in 2010 to that in 2011?
Give a very brief answer. 0.94. What is the ratio of the PPP conversion factor (LCU per international $) of Uruguay in 2010 to that in 2011?
Keep it short and to the point. 0.95. What is the ratio of the PPP conversion factor (LCU per international $) of Egypt, Arab Rep. in 2010 to that in 2012?
Make the answer very short. 0.89. What is the ratio of the PPP conversion factor (LCU per international $) in Tunisia in 2010 to that in 2012?
Offer a very short reply. 0.97. What is the ratio of the PPP conversion factor (LCU per international $) in Uruguay in 2010 to that in 2012?
Offer a very short reply. 0.9. What is the ratio of the PPP conversion factor (LCU per international $) of Egypt, Arab Rep. in 2010 to that in 2013?
Provide a succinct answer. 0.83. What is the ratio of the PPP conversion factor (LCU per international $) of Tunisia in 2010 to that in 2013?
Ensure brevity in your answer.  0.93. What is the ratio of the PPP conversion factor (LCU per international $) in Uruguay in 2010 to that in 2013?
Offer a terse response. 0.84. What is the ratio of the PPP conversion factor (LCU per international $) of Egypt, Arab Rep. in 2011 to that in 2012?
Make the answer very short. 0.95. What is the ratio of the PPP conversion factor (LCU per international $) in Tunisia in 2011 to that in 2012?
Ensure brevity in your answer.  0.97. What is the ratio of the PPP conversion factor (LCU per international $) in Uruguay in 2011 to that in 2012?
Make the answer very short. 0.94. What is the ratio of the PPP conversion factor (LCU per international $) in Egypt, Arab Rep. in 2011 to that in 2013?
Keep it short and to the point. 0.88. What is the ratio of the PPP conversion factor (LCU per international $) in Uruguay in 2011 to that in 2013?
Your answer should be compact. 0.88. What is the ratio of the PPP conversion factor (LCU per international $) of Egypt, Arab Rep. in 2012 to that in 2013?
Your response must be concise. 0.93. What is the ratio of the PPP conversion factor (LCU per international $) in Uruguay in 2012 to that in 2013?
Make the answer very short. 0.93. What is the difference between the highest and the second highest PPP conversion factor (LCU per international $) in Egypt, Arab Rep.?
Keep it short and to the point. 0.15. What is the difference between the highest and the second highest PPP conversion factor (LCU per international $) of Tunisia?
Keep it short and to the point. 0.03. What is the difference between the highest and the second highest PPP conversion factor (LCU per international $) in Uruguay?
Ensure brevity in your answer.  1.22. What is the difference between the highest and the lowest PPP conversion factor (LCU per international $) of Egypt, Arab Rep.?
Offer a terse response. 0.9. What is the difference between the highest and the lowest PPP conversion factor (LCU per international $) of Tunisia?
Offer a terse response. 0.11. What is the difference between the highest and the lowest PPP conversion factor (LCU per international $) of Uruguay?
Keep it short and to the point. 5.89. 